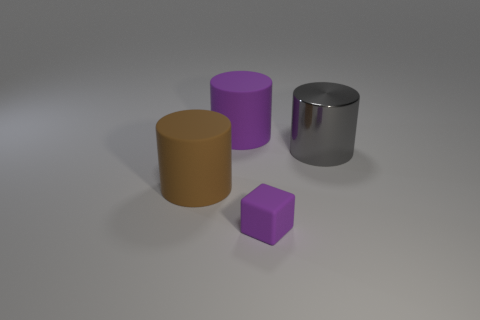Do the thing that is behind the big gray metallic cylinder and the matte thing right of the big purple rubber thing have the same color?
Provide a short and direct response. Yes. There is a rubber cylinder that is the same color as the matte block; what is its size?
Offer a very short reply. Large. Is the material of the object to the right of the purple block the same as the tiny purple object?
Provide a short and direct response. No. Is there another matte object that has the same color as the small matte thing?
Your answer should be very brief. Yes. Is the shape of the purple rubber object left of the small object the same as the big object to the right of the tiny purple rubber thing?
Provide a short and direct response. Yes. Is there a cylinder made of the same material as the gray object?
Ensure brevity in your answer.  No. How many gray objects are either matte cubes or big metallic cylinders?
Offer a very short reply. 1. There is a cylinder that is both to the left of the big gray metallic object and in front of the big purple cylinder; how big is it?
Your answer should be compact. Large. Is the number of purple cubes that are on the right side of the purple cylinder greater than the number of tiny red metal balls?
Provide a short and direct response. Yes. What number of cylinders are either metal things or big brown things?
Offer a terse response. 2. 